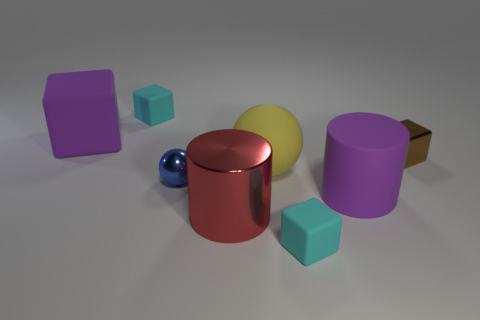There is a large rubber thing that is the same color as the large rubber cylinder; what is its shape? The object you’re referring to is not a cube. It appears to be a sphere, which is in the same color palette as the rubber cylinder in the image, exhibiting a glossy, reflective surface. 